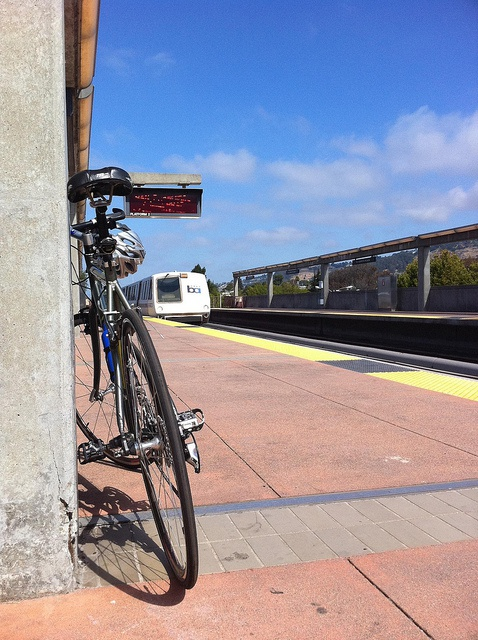Describe the objects in this image and their specific colors. I can see bicycle in lightgray, black, gray, tan, and darkgray tones and train in lightgray, white, gray, black, and darkgray tones in this image. 